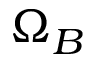Convert formula to latex. <formula><loc_0><loc_0><loc_500><loc_500>\Omega _ { B }</formula> 